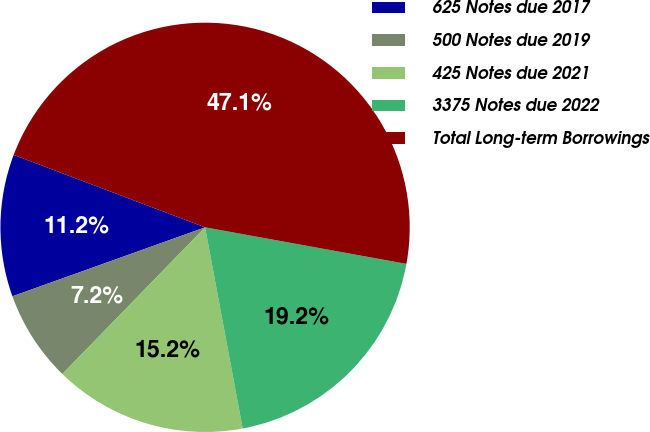Convert chart. <chart><loc_0><loc_0><loc_500><loc_500><pie_chart><fcel>625 Notes due 2017<fcel>500 Notes due 2019<fcel>425 Notes due 2021<fcel>3375 Notes due 2022<fcel>Total Long-term Borrowings<nl><fcel>11.23%<fcel>7.25%<fcel>15.22%<fcel>19.2%<fcel>47.1%<nl></chart> 